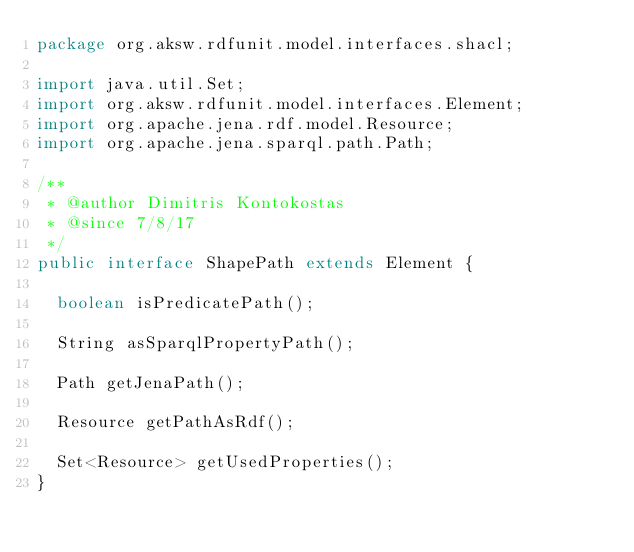Convert code to text. <code><loc_0><loc_0><loc_500><loc_500><_Java_>package org.aksw.rdfunit.model.interfaces.shacl;

import java.util.Set;
import org.aksw.rdfunit.model.interfaces.Element;
import org.apache.jena.rdf.model.Resource;
import org.apache.jena.sparql.path.Path;

/**
 * @author Dimitris Kontokostas
 * @since 7/8/17
 */
public interface ShapePath extends Element {

  boolean isPredicatePath();

  String asSparqlPropertyPath();

  Path getJenaPath();

  Resource getPathAsRdf();

  Set<Resource> getUsedProperties();
}
</code> 